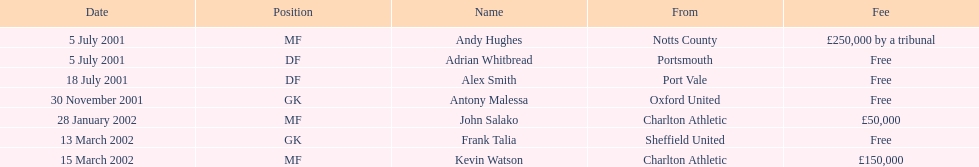Before august 1, 2001, who carried out a transfer? Andy Hughes, Adrian Whitbread, Alex Smith. 